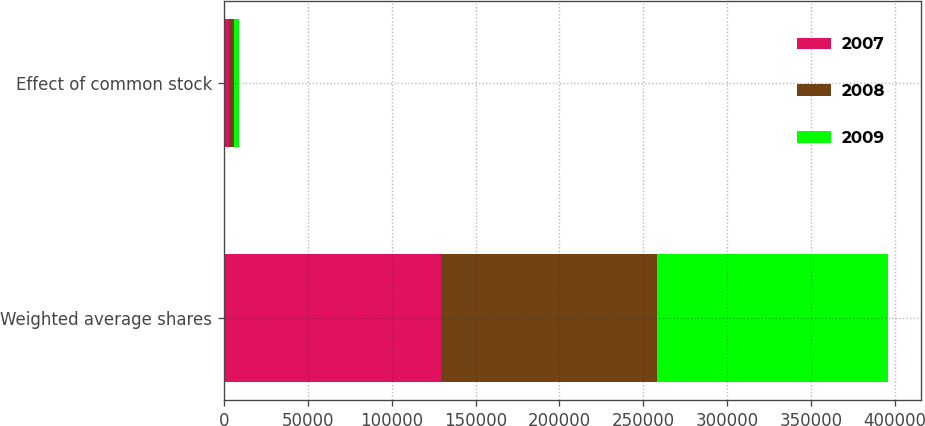Convert chart to OTSL. <chart><loc_0><loc_0><loc_500><loc_500><stacked_bar_chart><ecel><fcel>Weighted average shares<fcel>Effect of common stock<nl><fcel>2007<fcel>129462<fcel>2786<nl><fcel>2008<fcel>128533<fcel>3117<nl><fcel>2009<fcel>137639<fcel>3305<nl></chart> 